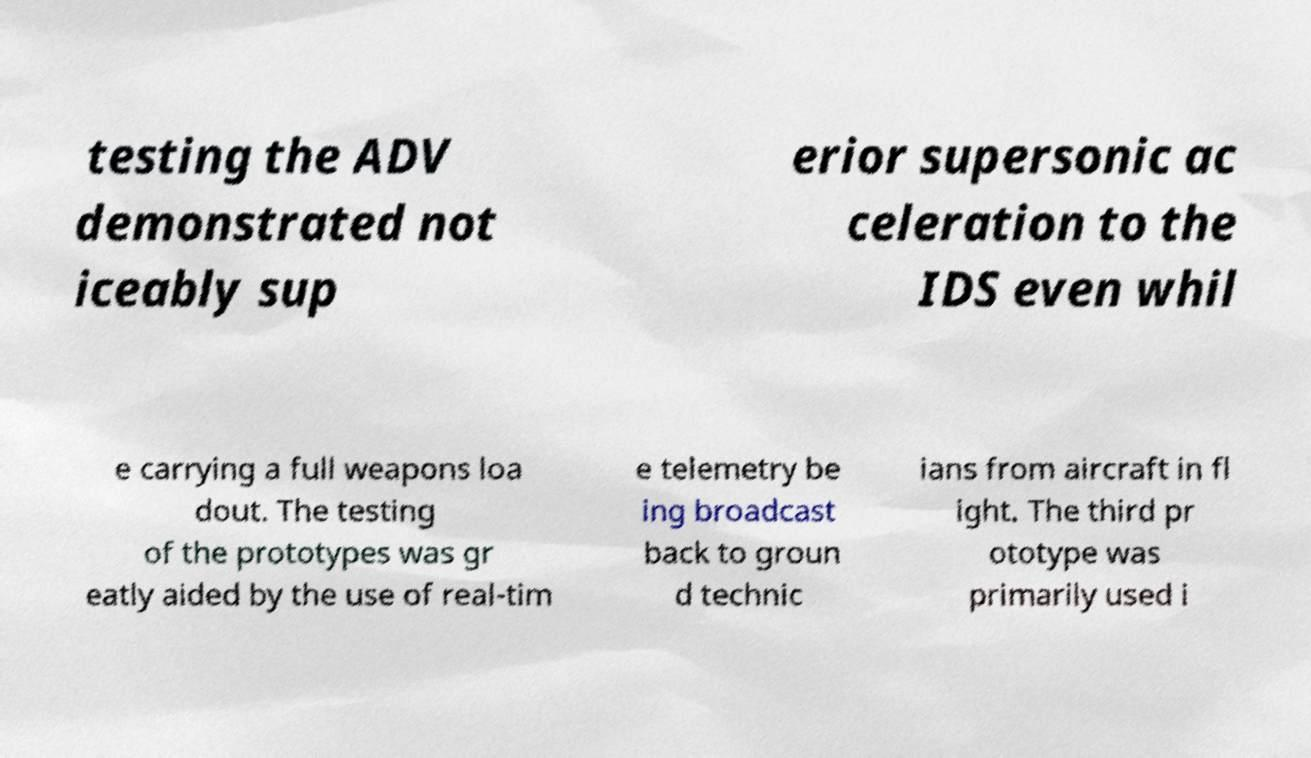For documentation purposes, I need the text within this image transcribed. Could you provide that? testing the ADV demonstrated not iceably sup erior supersonic ac celeration to the IDS even whil e carrying a full weapons loa dout. The testing of the prototypes was gr eatly aided by the use of real-tim e telemetry be ing broadcast back to groun d technic ians from aircraft in fl ight. The third pr ototype was primarily used i 